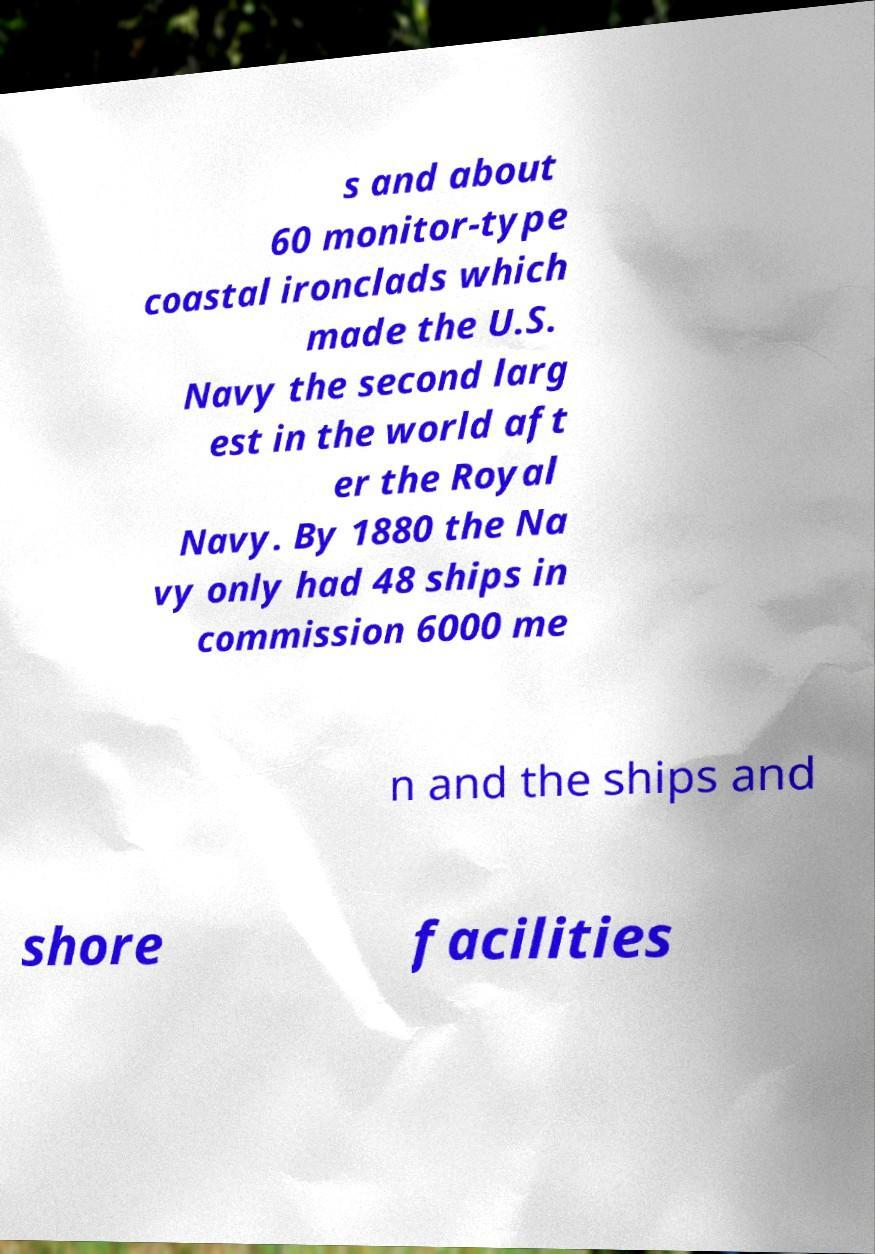Could you extract and type out the text from this image? s and about 60 monitor-type coastal ironclads which made the U.S. Navy the second larg est in the world aft er the Royal Navy. By 1880 the Na vy only had 48 ships in commission 6000 me n and the ships and shore facilities 